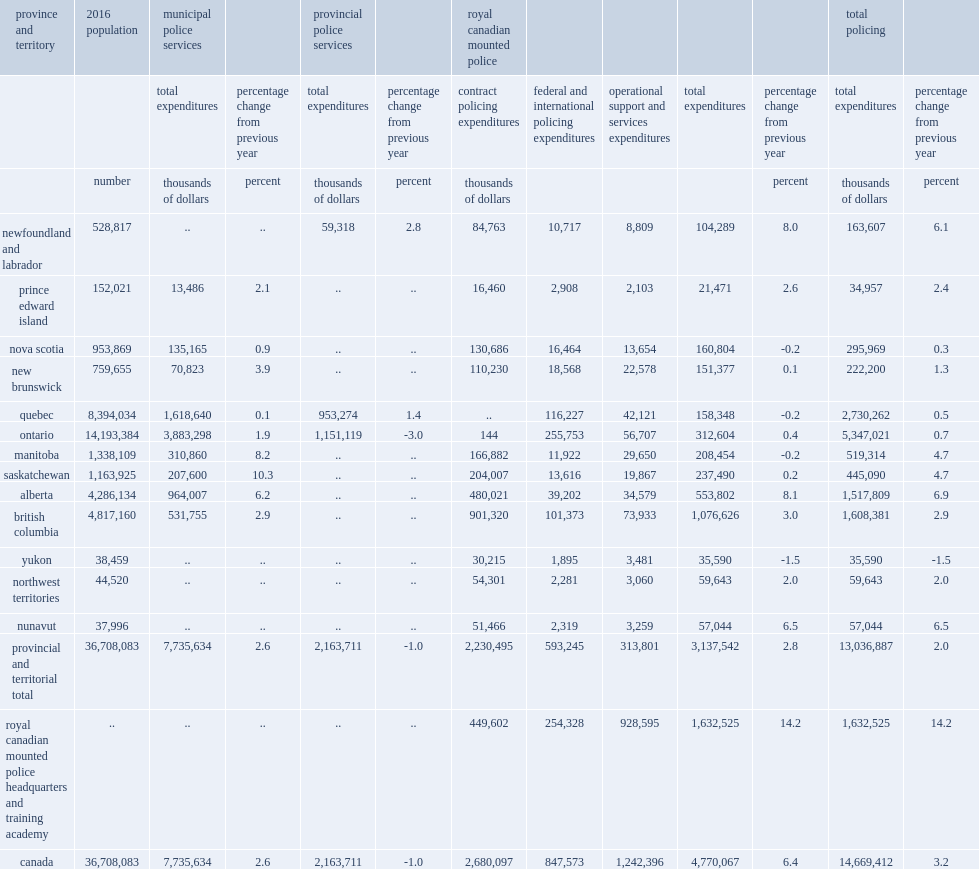What did total operating expenditures for all police services across canada in 2016/2017 amount to in current dollars? 14669412. Of the total operating expenditures for canada in current dollars, how many was associated with stand-alone municipal police services in 2016/2017? 7735634.0. Of the total operating expenditures for canada in current dollars, what was the percentage of expenditures associated with stand-alone municipal police services in 2016/2017? 0.527331. Of the total operating expenditures for canada in current dollars, how many did the percentage of expenditures associated with stand-alone municipal police services increase from 2016? 2.6. Of the total operating expenditures for canada in current dollars, how many were provincial police services reported spending in 2016/2017? 2163711.0. Of the total operating expenditures for canada in current dollars, what was the percentage of provincial police services being reported spending in 2016/2017? 0.147498. Of the total operating expenditures for canada in current dollars, how many was the royal canadian mounted police reported in expenditures in 2016/2017? 4770067.0. Of the total operating expenditures for canada in current dollars, what was the reported percentage of expenditures spent by the royal canadian mounted police in 2016/2017? 0.325171. Of the total operating expenditures for canada in current dollars, how many did the percentage of expenditures spent by the royal canadian mounted police increase from 2016? 6.4. 